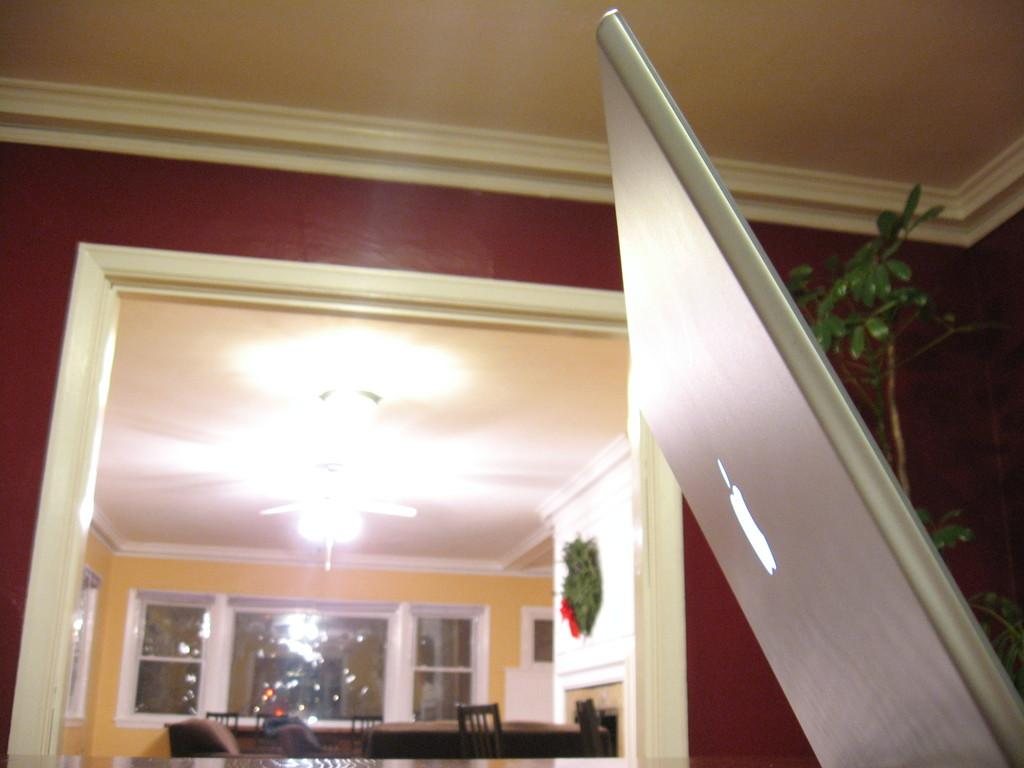What electronic device is located on the right side of the image? There is a laptop on the right side of the image. What type of plant is on the right side of the image? There is a tree on the right side of the image. What architectural features can be seen in the background of the image? There is a door, windows, a light, a table, and chairs in the background of the image. What type of health supplement is visible on the table in the image? There is no health supplement present in the image. What type of carriage can be seen in the background of the image? There is no carriage present in the image. 